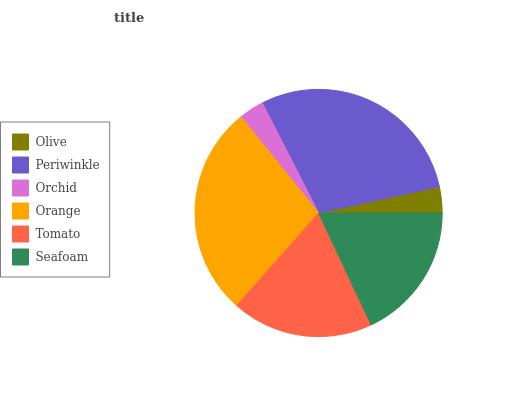Is Orchid the minimum?
Answer yes or no. Yes. Is Periwinkle the maximum?
Answer yes or no. Yes. Is Periwinkle the minimum?
Answer yes or no. No. Is Orchid the maximum?
Answer yes or no. No. Is Periwinkle greater than Orchid?
Answer yes or no. Yes. Is Orchid less than Periwinkle?
Answer yes or no. Yes. Is Orchid greater than Periwinkle?
Answer yes or no. No. Is Periwinkle less than Orchid?
Answer yes or no. No. Is Tomato the high median?
Answer yes or no. Yes. Is Seafoam the low median?
Answer yes or no. Yes. Is Seafoam the high median?
Answer yes or no. No. Is Periwinkle the low median?
Answer yes or no. No. 